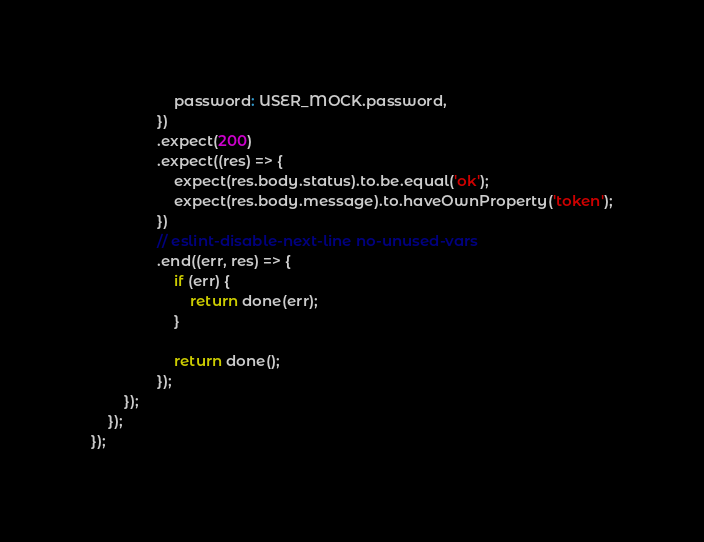Convert code to text. <code><loc_0><loc_0><loc_500><loc_500><_JavaScript_>					password: USER_MOCK.password,
				})
				.expect(200)
				.expect((res) => {
					expect(res.body.status).to.be.equal('ok');
					expect(res.body.message).to.haveOwnProperty('token');
				})
				// eslint-disable-next-line no-unused-vars
				.end((err, res) => {
					if (err) {
						return done(err);
					}

					return done();
				});
		});
	});
});
</code> 